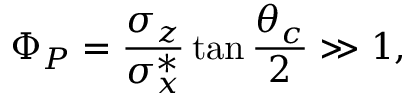<formula> <loc_0><loc_0><loc_500><loc_500>\Phi _ { P } = \frac { \sigma _ { z } } { \sigma _ { x } ^ { * } } \tan \frac { \theta _ { c } } { 2 } \gg 1 ,</formula> 